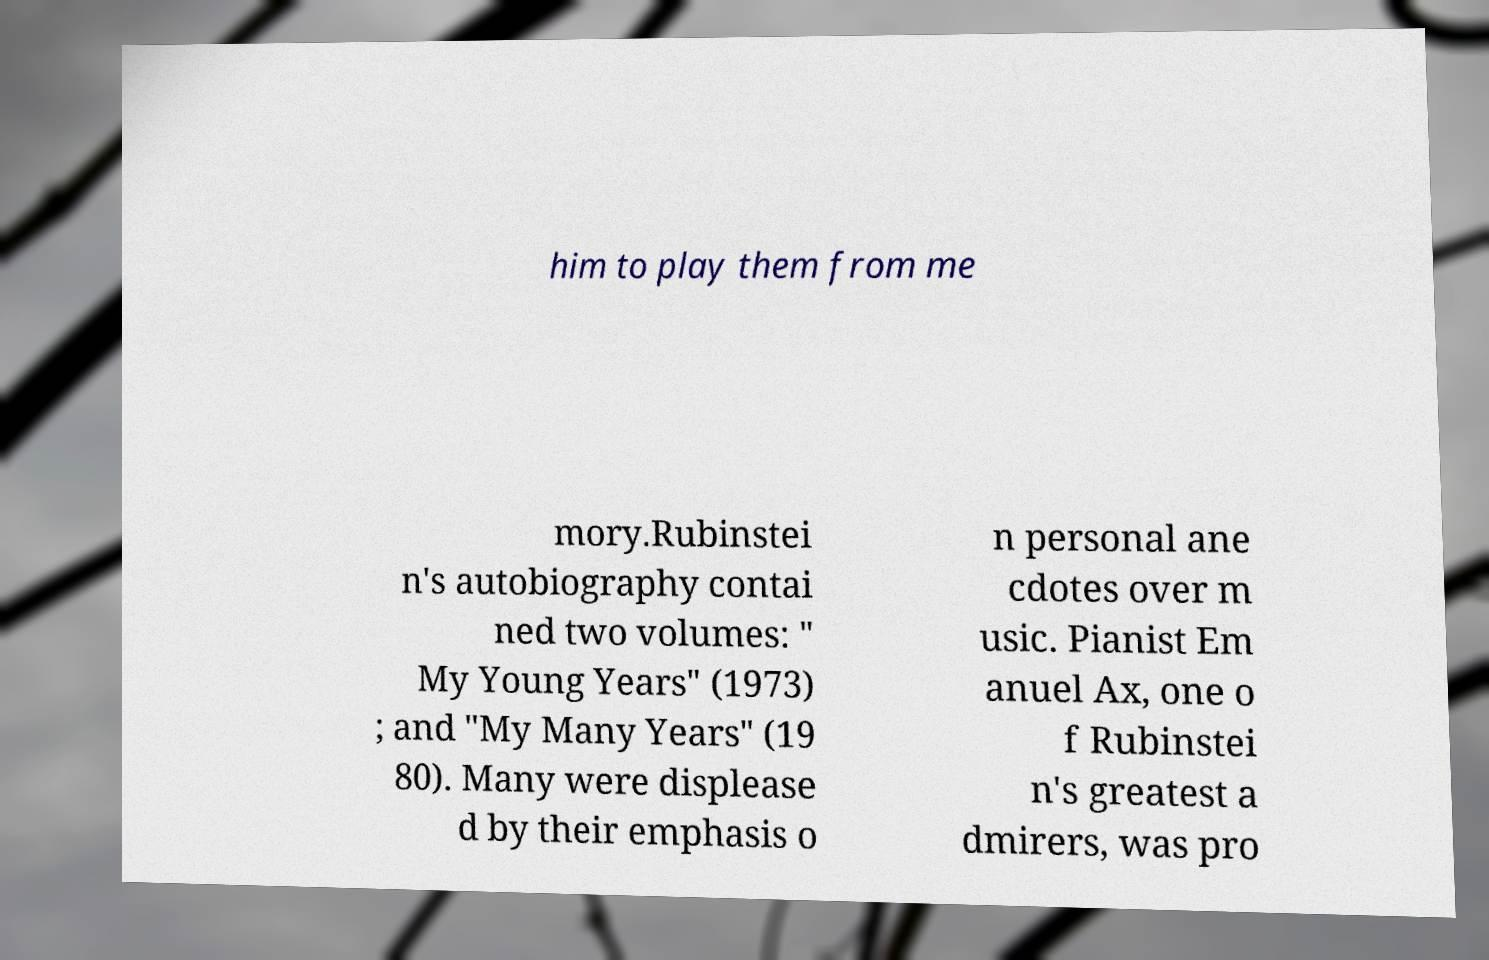Please read and relay the text visible in this image. What does it say? him to play them from me mory.Rubinstei n's autobiography contai ned two volumes: " My Young Years" (1973) ; and "My Many Years" (19 80). Many were displease d by their emphasis o n personal ane cdotes over m usic. Pianist Em anuel Ax, one o f Rubinstei n's greatest a dmirers, was pro 